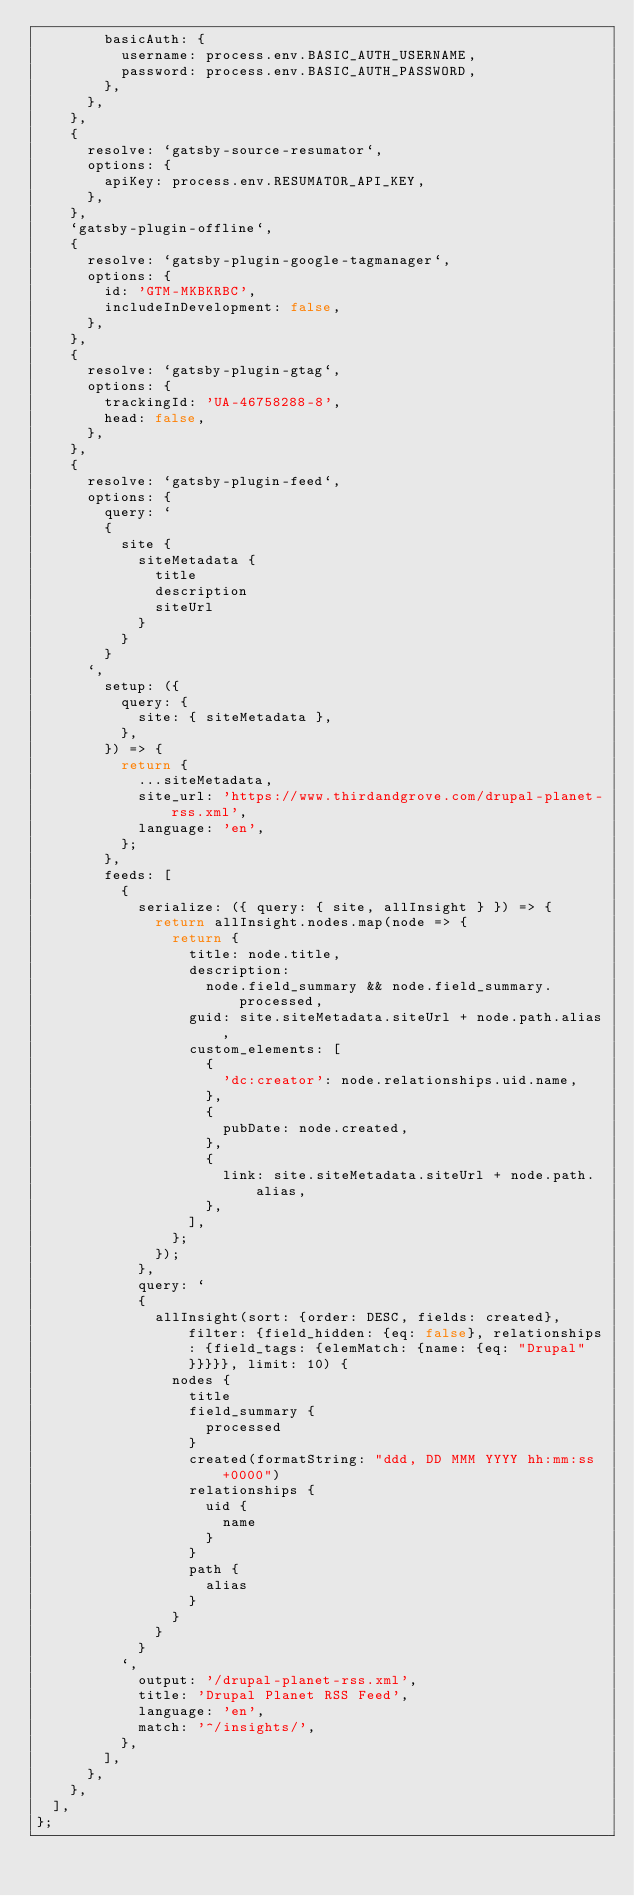Convert code to text. <code><loc_0><loc_0><loc_500><loc_500><_JavaScript_>        basicAuth: {
          username: process.env.BASIC_AUTH_USERNAME,
          password: process.env.BASIC_AUTH_PASSWORD,
        },
      },
    },
    {
      resolve: `gatsby-source-resumator`,
      options: {
        apiKey: process.env.RESUMATOR_API_KEY,
      },
    },
    `gatsby-plugin-offline`,
    {
      resolve: `gatsby-plugin-google-tagmanager`,
      options: {
        id: 'GTM-MKBKRBC',
        includeInDevelopment: false,
      },
    },
    {
      resolve: `gatsby-plugin-gtag`,
      options: {
        trackingId: 'UA-46758288-8',
        head: false,
      },
    },
    {
      resolve: `gatsby-plugin-feed`,
      options: {
        query: `
        {
          site {
            siteMetadata {
              title
              description
              siteUrl
            }
          }
        }
      `,
        setup: ({
          query: {
            site: { siteMetadata },
          },
        }) => {
          return {
            ...siteMetadata,
            site_url: 'https://www.thirdandgrove.com/drupal-planet-rss.xml',
            language: 'en',
          };
        },
        feeds: [
          {
            serialize: ({ query: { site, allInsight } }) => {
              return allInsight.nodes.map(node => {
                return {
                  title: node.title,
                  description:
                    node.field_summary && node.field_summary.processed,
                  guid: site.siteMetadata.siteUrl + node.path.alias,
                  custom_elements: [
                    {
                      'dc:creator': node.relationships.uid.name,
                    },
                    {
                      pubDate: node.created,
                    },
                    {
                      link: site.siteMetadata.siteUrl + node.path.alias,
                    },
                  ],
                };
              });
            },
            query: `
            {
              allInsight(sort: {order: DESC, fields: created}, filter: {field_hidden: {eq: false}, relationships: {field_tags: {elemMatch: {name: {eq: "Drupal"}}}}}, limit: 10) {
                nodes {
                  title
                  field_summary {
                    processed
                  }
                  created(formatString: "ddd, DD MMM YYYY hh:mm:ss +0000")
                  relationships {
                    uid {
                      name
                    }
                  }
                  path {
                    alias
                  }
                }
              }
            }
          `,
            output: '/drupal-planet-rss.xml',
            title: 'Drupal Planet RSS Feed',
            language: 'en',
            match: '^/insights/',
          },
        ],
      },
    },
  ],
};
</code> 